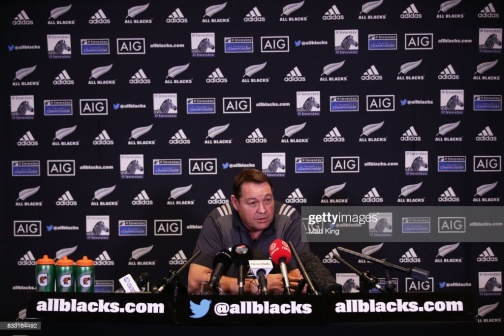What are the logos in the background representing? The background is adorned with logos representing various sponsors and partners associated with the All Blacks rugby team. Prominent logos include 'allblacks.com', the official website of the team, and 'AIG', a major sponsor. The presence of these logos signifies the commercial partnerships that support the team. Branding in such a fashion is common in sports to provide visibility to sponsors during media-covered events. If you were to make a wild guess, what could one of the conversations in this image be about? If I were to let my imagination soar, it's possible that the conversation in this image could be about an upcoming match where the All Blacks are set to face a legendary rival team, with strategies being revealed and the stakes being discussed. Discussing player conditions, strategic changes, and perhaps unveiling new partnerships could also be part of this interaction. There might be a buzz about a newly discovered technique that's poised to revolutionize the game, and the man at the center is passionately elaborating on it, keeping the press on the edge of their seats. 